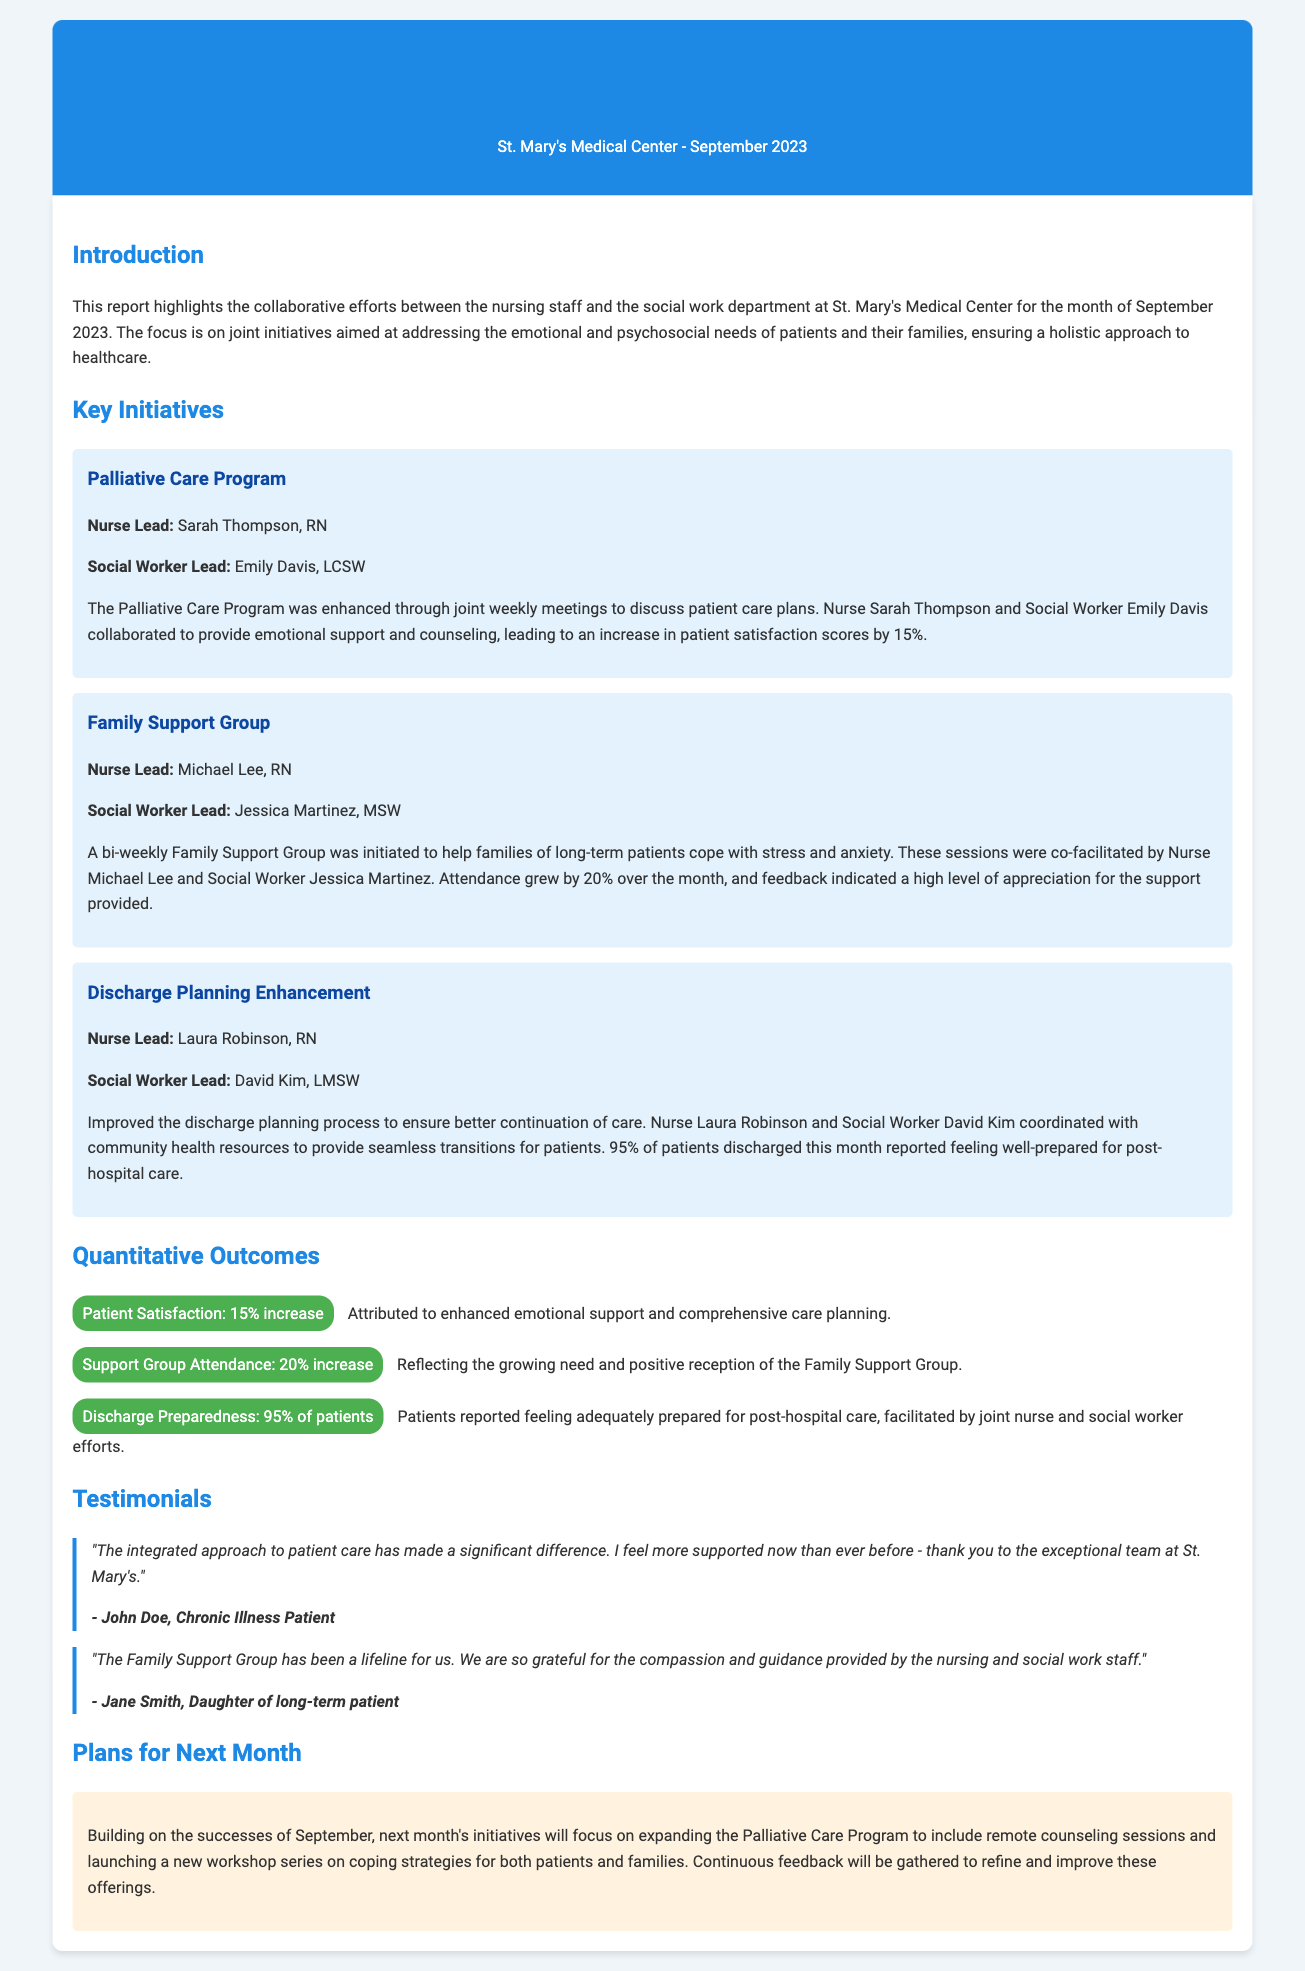what is the date of the report? The report is dated for the month of September 2023, as mentioned in the header.
Answer: September 2023 who leads the Palliative Care Program? The Palliative Care Program is led by Nurse Sarah Thompson and Social Worker Emily Davis.
Answer: Sarah Thompson, Emily Davis what was the increase in patient satisfaction scores? The increase in patient satisfaction scores attributed to the Palliative Care Program is stated to be 15%.
Answer: 15% how often does the Family Support Group meet? The Family Support Group is stated to meet bi-weekly in the report.
Answer: Bi-weekly what percentage of patients felt well-prepared for post-hospital care? The report indicates that 95% of patients reported feeling well-prepared for post-hospital care.
Answer: 95% what additional service is planned for next month regarding the Palliative Care Program? The planned additional service includes remote counseling sessions for the Palliative Care Program.
Answer: Remote counseling sessions what was the attendance growth percentage for the Family Support Group? The document specifies that the attendance for the Family Support Group grew by 20% over the month.
Answer: 20% who is the author of the testimonials provided in the report? The testimonials are provided by John Doe, a chronic illness patient, and Jane Smith, the daughter of a long-term patient.
Answer: John Doe, Jane Smith 